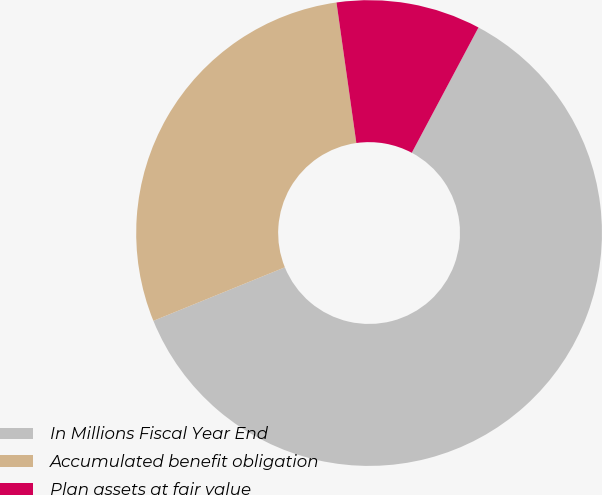Convert chart. <chart><loc_0><loc_0><loc_500><loc_500><pie_chart><fcel>In Millions Fiscal Year End<fcel>Accumulated benefit obligation<fcel>Plan assets at fair value<nl><fcel>61.07%<fcel>28.92%<fcel>10.02%<nl></chart> 